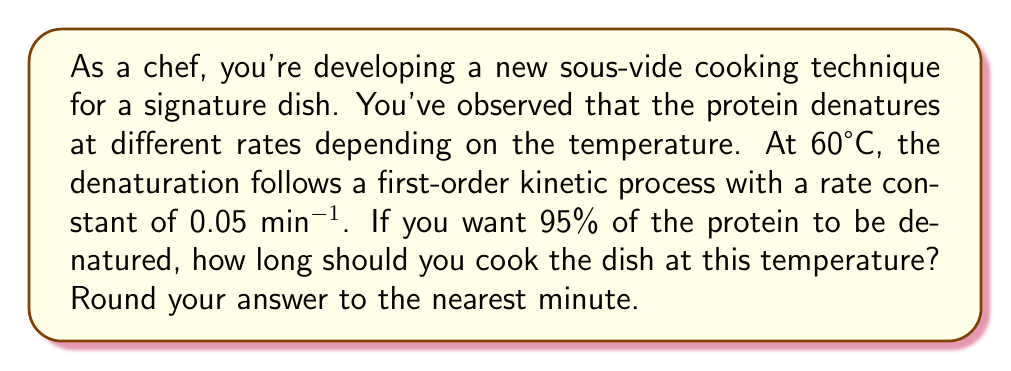Give your solution to this math problem. Let's approach this step-by-step using principles from statistical mechanics and chemical kinetics:

1) In first-order kinetics, the rate of change of the concentration of the reactant (in this case, the non-denatured protein) is proportional to its concentration:

   $$\frac{d[A]}{dt} = -k[A]$$

   where $[A]$ is the concentration of non-denatured protein, $t$ is time, and $k$ is the rate constant.

2) The integrated form of this equation is:

   $$\ln\frac{[A]}{[A]_0} = -kt$$

   where $[A]_0$ is the initial concentration of non-denatured protein.

3) We want 95% of the protein to be denatured, which means 5% remains non-denatured. So:

   $$\frac{[A]}{[A]_0} = 0.05$$

4) Substituting this into our equation:

   $$\ln(0.05) = -kt$$

5) Solving for $t$:

   $$t = -\frac{\ln(0.05)}{k}$$

6) We're given $k = 0.05$ min^(-1). Let's substitute this:

   $$t = -\frac{\ln(0.05)}{0.05} \approx 59.91 \text{ minutes}$$

7) Rounding to the nearest minute:

   $$t \approx 60 \text{ minutes}$$
Answer: 60 minutes 